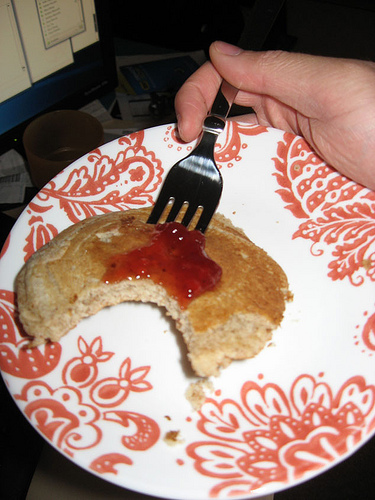<image>
Is the food on the table? No. The food is not positioned on the table. They may be near each other, but the food is not supported by or resting on top of the table. 